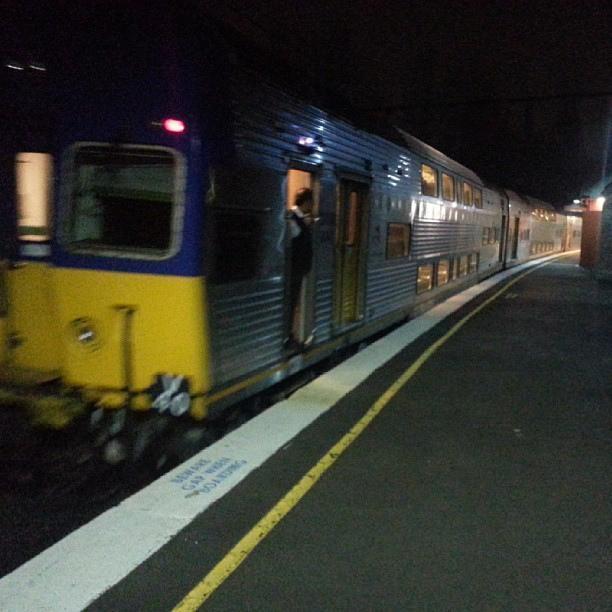How many people are there?
Give a very brief answer. 1. How many rolls of white toilet paper are in the bathroom?
Give a very brief answer. 0. 